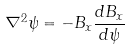<formula> <loc_0><loc_0><loc_500><loc_500>\nabla ^ { 2 } \psi = - B _ { x } \frac { d B _ { x } } { d \psi }</formula> 